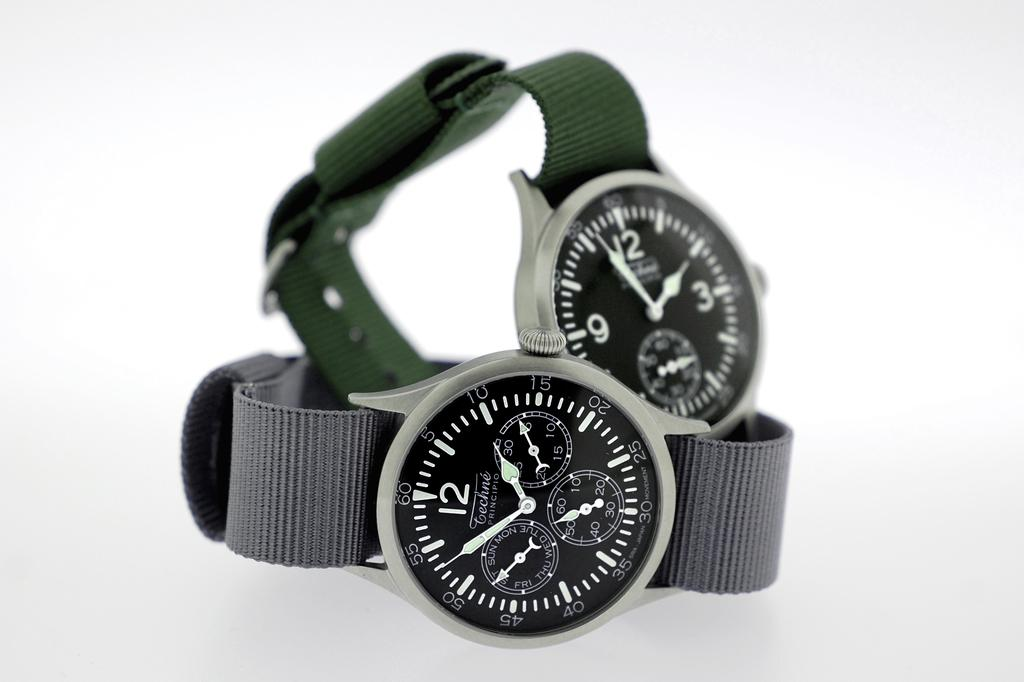<image>
Offer a succinct explanation of the picture presented. Two watches with cloth bands, the closest one says Techne Principio on the face of it. 